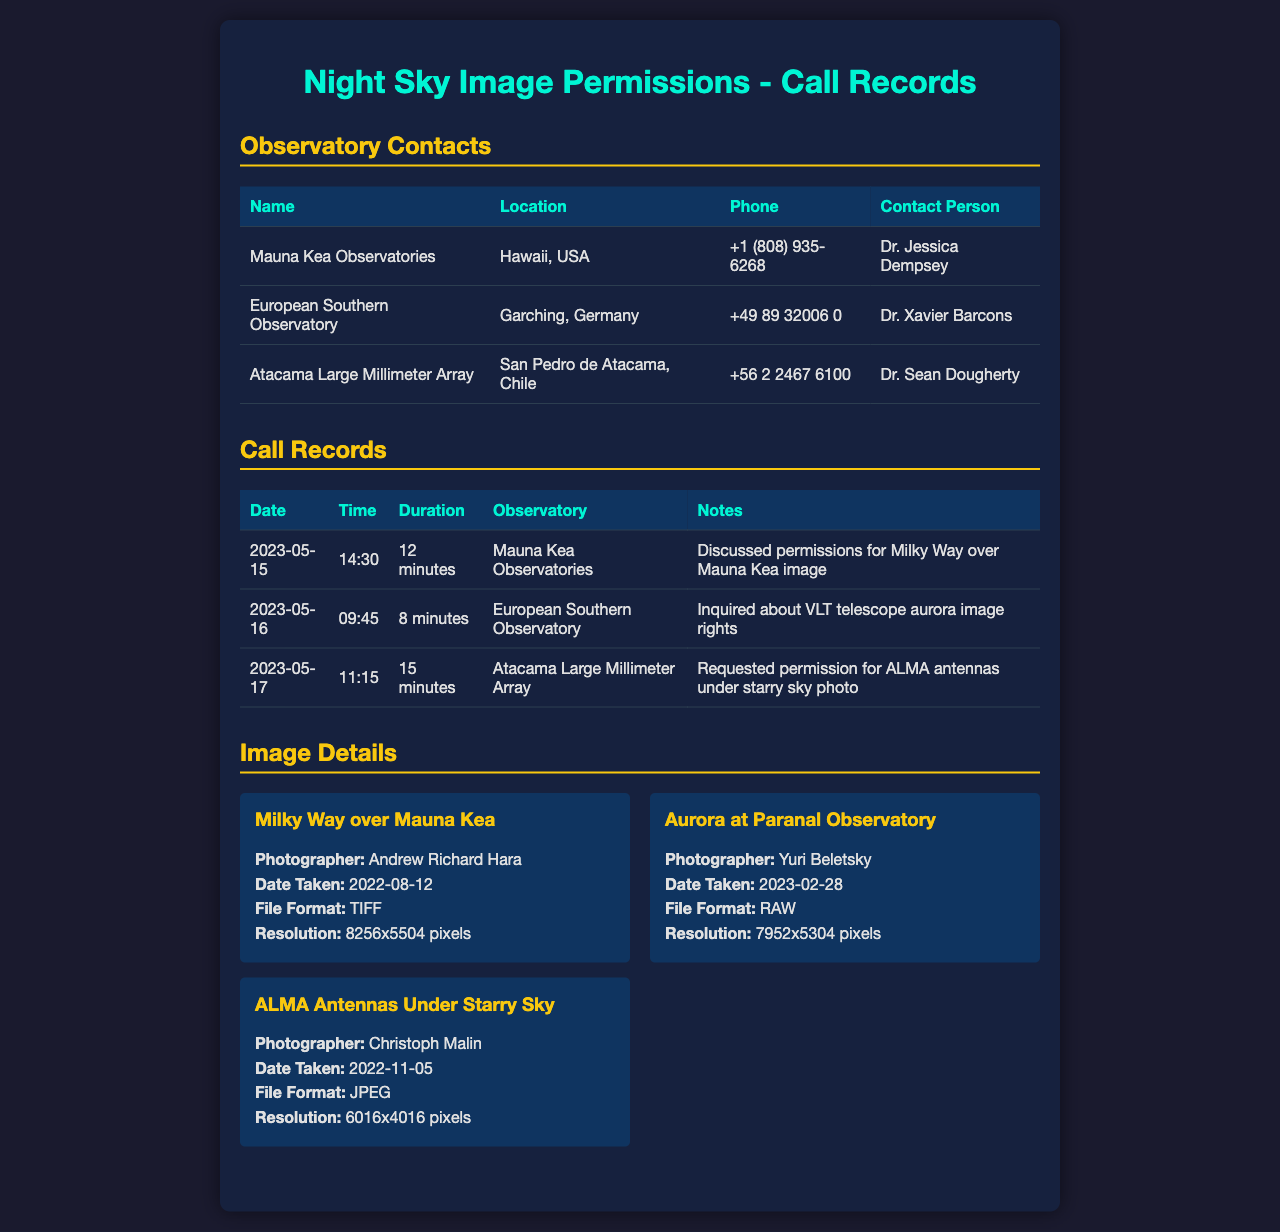What is the name of the observatory located in Hawaii? The document lists Mauna Kea Observatories as the one located in Hawaii, USA.
Answer: Mauna Kea Observatories Who is the contact person for the European Southern Observatory? The contact person is specified in the document as Dr. Xavier Barcons.
Answer: Dr. Xavier Barcons What is the duration of the call made to the Atacama Large Millimeter Array? The document shows that the call lasted for 15 minutes.
Answer: 15 minutes On what date was permission discussed for the Milky Way over Mauna Kea image? The date mentioned for this discussion in the document is May 15, 2023.
Answer: 2023-05-15 Which image has a photographer named Christoph Malin? According to the document, the image by Christoph Malin is titled "ALMA Antennas Under Starry Sky."
Answer: ALMA Antennas Under Starry Sky How many minutes was the call to the European Southern Observatory? The document specifies that the call duration was 8 minutes.
Answer: 8 minutes What is the file format of the "Aurora at Paranal Observatory" image? The document states that the file format for this image is RAW.
Answer: RAW Where is the Atacama Large Millimeter Array located? The document indicates that it is located in San Pedro de Atacama, Chile.
Answer: San Pedro de Atacama, Chile What resolution is the image "Milky Way over Mauna Kea"? The resolution mentioned for this image in the document is 8256x5504 pixels.
Answer: 8256x5504 pixels 